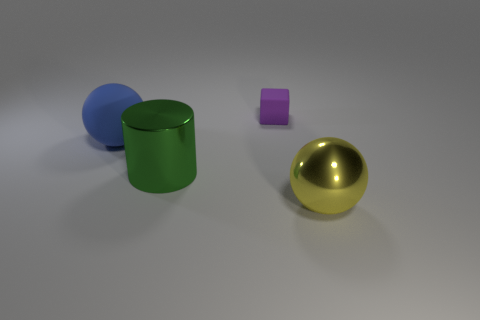Add 4 big metal objects. How many objects exist? 8 Subtract all cylinders. How many objects are left? 3 Add 1 tiny green cylinders. How many tiny green cylinders exist? 1 Subtract 1 purple blocks. How many objects are left? 3 Subtract all blue objects. Subtract all metallic things. How many objects are left? 1 Add 2 big blue objects. How many big blue objects are left? 3 